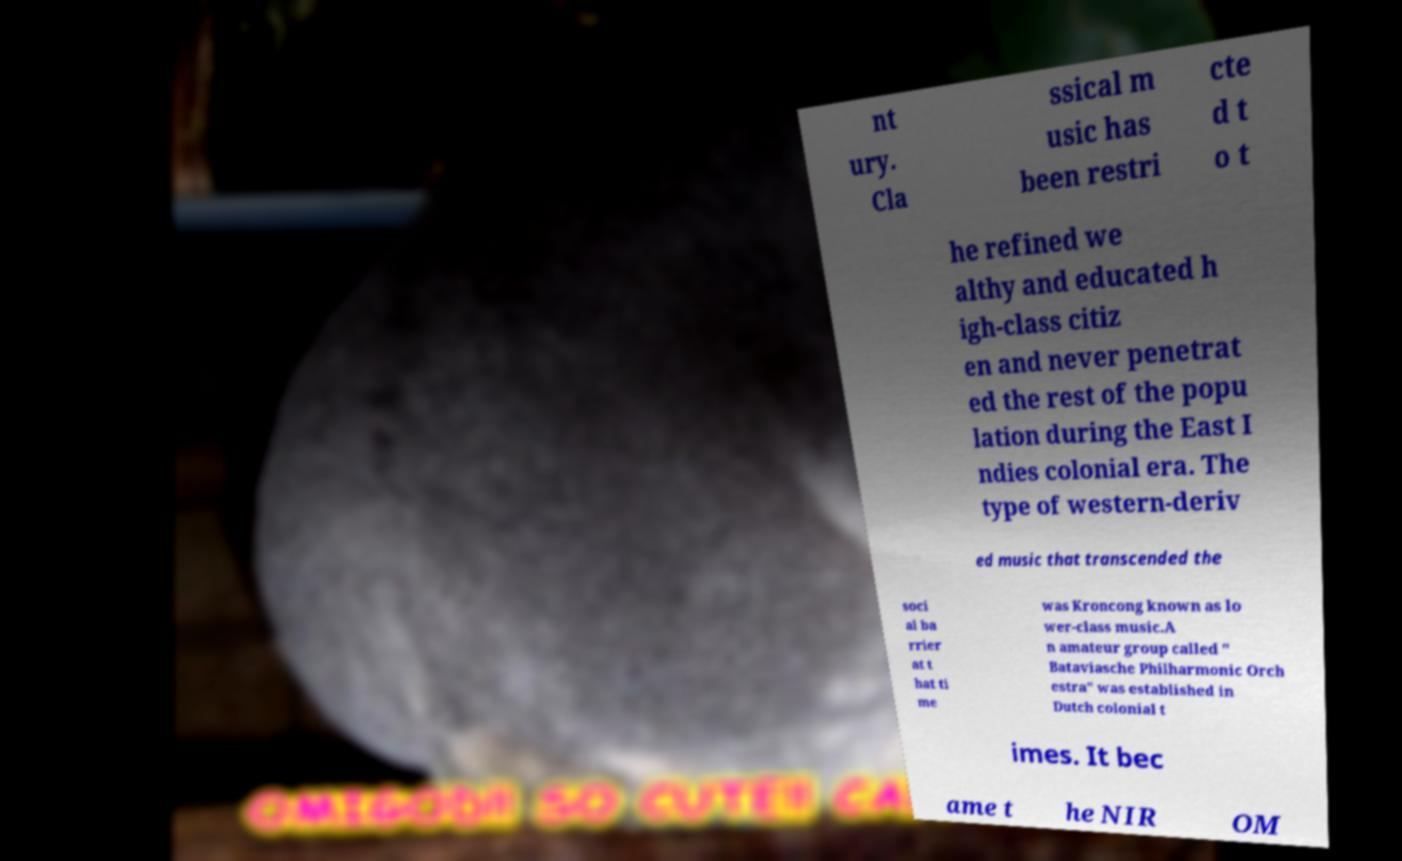There's text embedded in this image that I need extracted. Can you transcribe it verbatim? nt ury. Cla ssical m usic has been restri cte d t o t he refined we althy and educated h igh-class citiz en and never penetrat ed the rest of the popu lation during the East I ndies colonial era. The type of western-deriv ed music that transcended the soci al ba rrier at t hat ti me was Kroncong known as lo wer-class music.A n amateur group called " Bataviasche Philharmonic Orch estra" was established in Dutch colonial t imes. It bec ame t he NIR OM 